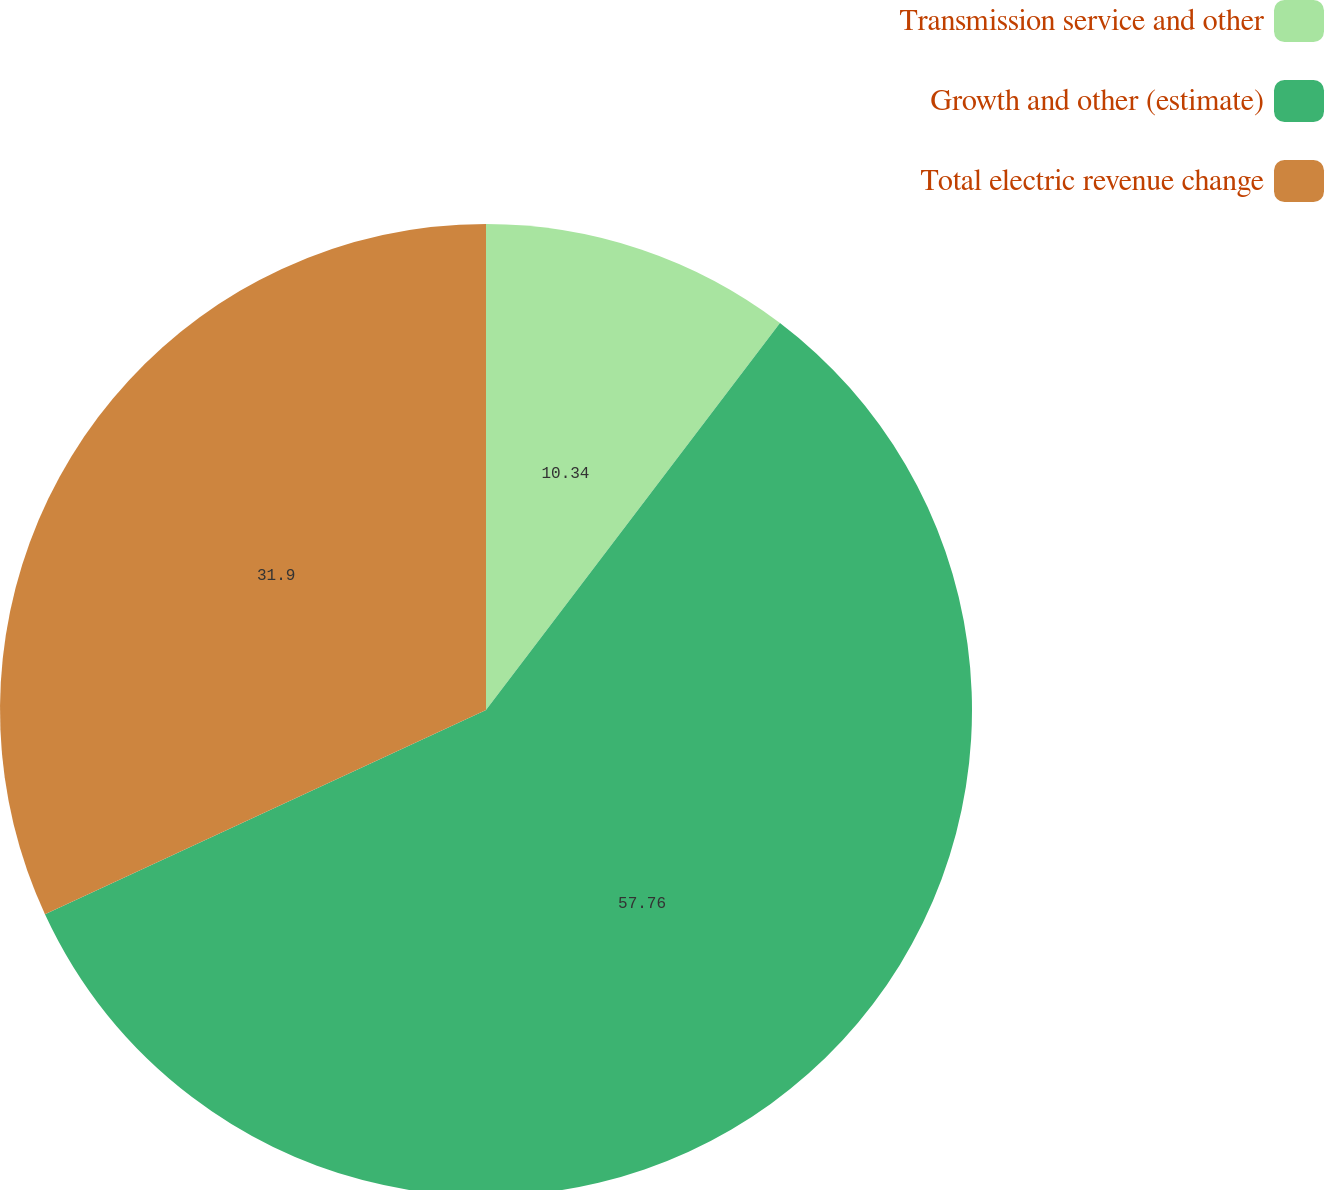<chart> <loc_0><loc_0><loc_500><loc_500><pie_chart><fcel>Transmission service and other<fcel>Growth and other (estimate)<fcel>Total electric revenue change<nl><fcel>10.34%<fcel>57.76%<fcel>31.9%<nl></chart> 